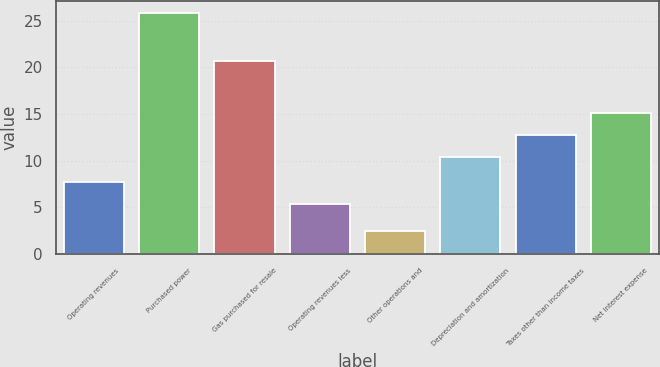Convert chart to OTSL. <chart><loc_0><loc_0><loc_500><loc_500><bar_chart><fcel>Operating revenues<fcel>Purchased power<fcel>Gas purchased for resale<fcel>Operating revenues less<fcel>Other operations and<fcel>Depreciation and amortization<fcel>Taxes other than income taxes<fcel>Net interest expense<nl><fcel>7.73<fcel>25.8<fcel>20.7<fcel>5.4<fcel>2.5<fcel>10.4<fcel>12.73<fcel>15.06<nl></chart> 